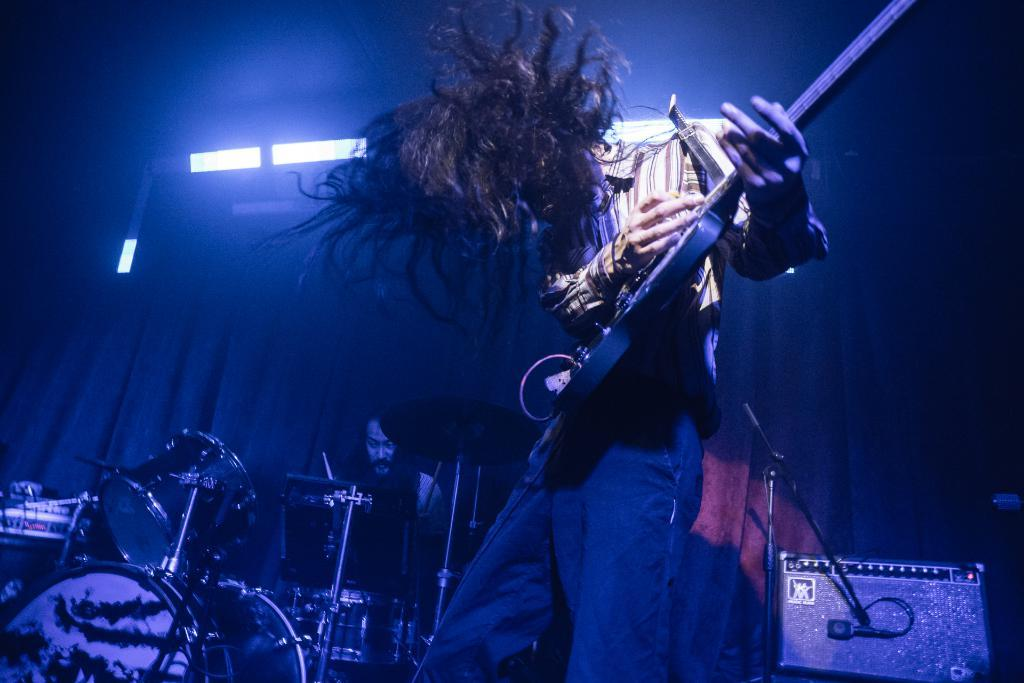What is the man in the image doing? The man is playing guitar in the image. What is the other person in the image doing? The other person is playing drums in the image. Can you describe the object on the right side of the image? There is a speaker in the right side of the image. What can be seen in the background of the image? There is a curtain and lights in the background of the image. What rule is being enforced by the guitar player in the image? There is no indication in the image that the guitar player is enforcing any rules. 